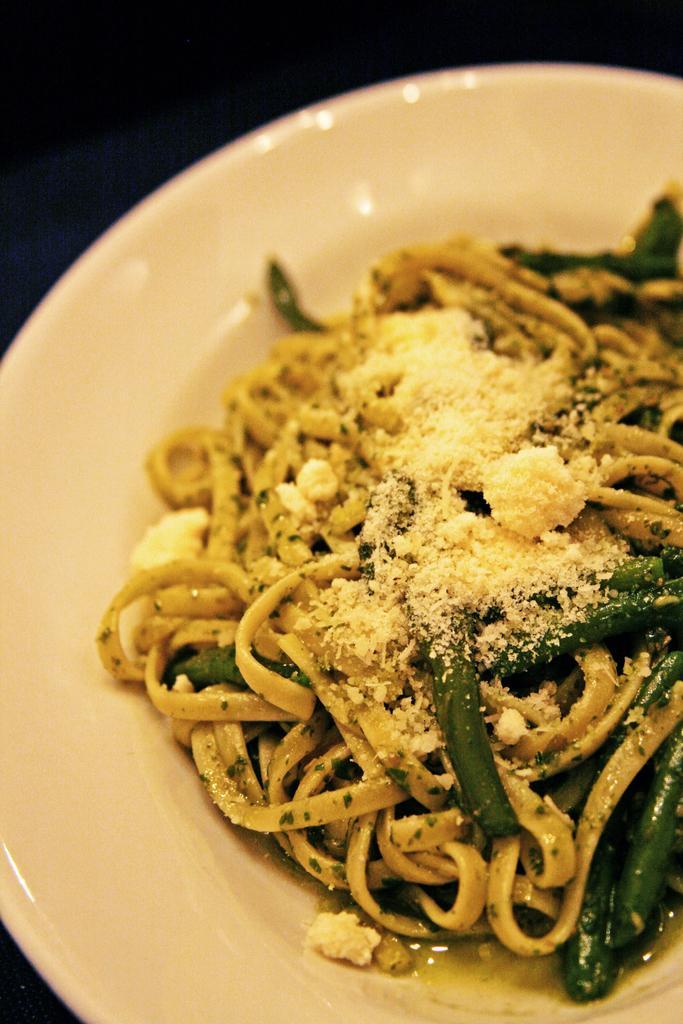How would you summarize this image in a sentence or two? In the image we can see a plate, white in color. In the plate, we can see food item, like noodles and cut vegetables and the plate is kept on the dark surface. 